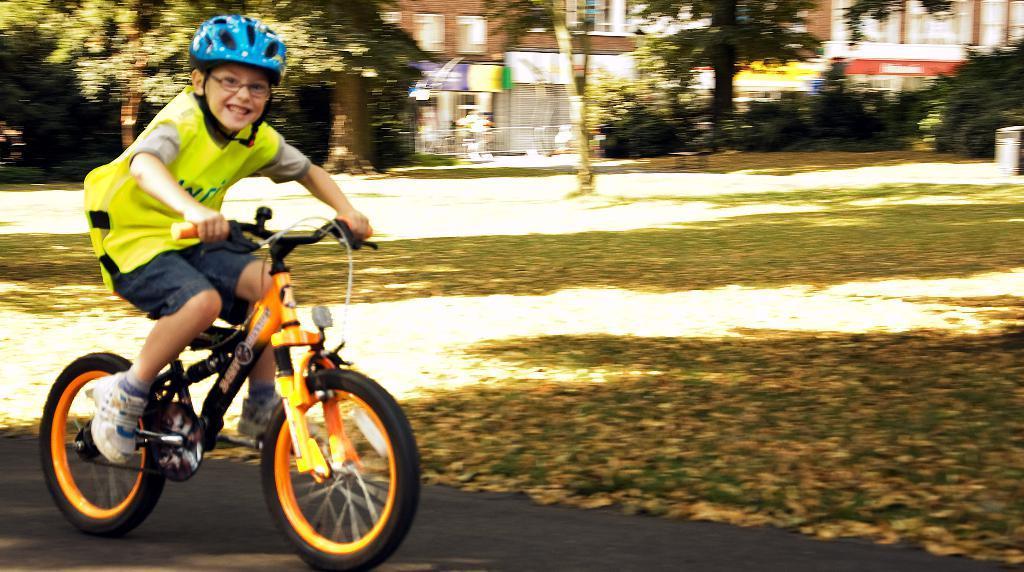In one or two sentences, can you explain what this image depicts? This picture shows a boy riding a bicycle. He is wearing helmet and spectacles. In the background there is a open land and some trees here. Behind the trees, there are some buildings too. 